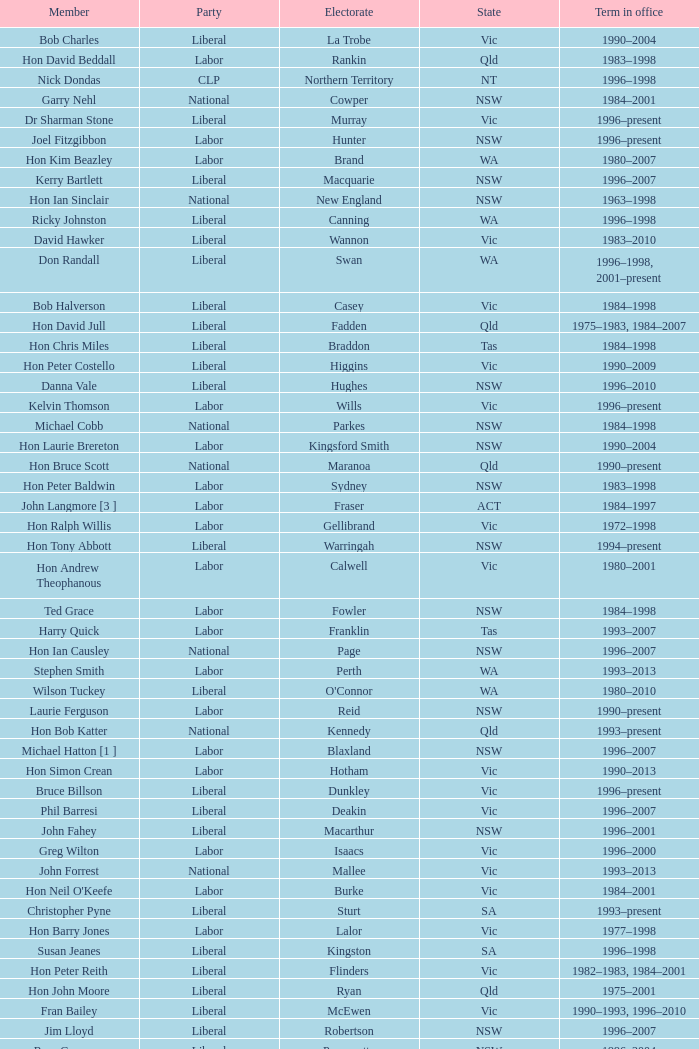Could you parse the entire table? {'header': ['Member', 'Party', 'Electorate', 'State', 'Term in office'], 'rows': [['Bob Charles', 'Liberal', 'La Trobe', 'Vic', '1990–2004'], ['Hon David Beddall', 'Labor', 'Rankin', 'Qld', '1983–1998'], ['Nick Dondas', 'CLP', 'Northern Territory', 'NT', '1996–1998'], ['Garry Nehl', 'National', 'Cowper', 'NSW', '1984–2001'], ['Dr Sharman Stone', 'Liberal', 'Murray', 'Vic', '1996–present'], ['Joel Fitzgibbon', 'Labor', 'Hunter', 'NSW', '1996–present'], ['Hon Kim Beazley', 'Labor', 'Brand', 'WA', '1980–2007'], ['Kerry Bartlett', 'Liberal', 'Macquarie', 'NSW', '1996–2007'], ['Hon Ian Sinclair', 'National', 'New England', 'NSW', '1963–1998'], ['Ricky Johnston', 'Liberal', 'Canning', 'WA', '1996–1998'], ['David Hawker', 'Liberal', 'Wannon', 'Vic', '1983–2010'], ['Don Randall', 'Liberal', 'Swan', 'WA', '1996–1998, 2001–present'], ['Bob Halverson', 'Liberal', 'Casey', 'Vic', '1984–1998'], ['Hon David Jull', 'Liberal', 'Fadden', 'Qld', '1975–1983, 1984–2007'], ['Hon Chris Miles', 'Liberal', 'Braddon', 'Tas', '1984–1998'], ['Hon Peter Costello', 'Liberal', 'Higgins', 'Vic', '1990–2009'], ['Danna Vale', 'Liberal', 'Hughes', 'NSW', '1996–2010'], ['Kelvin Thomson', 'Labor', 'Wills', 'Vic', '1996–present'], ['Michael Cobb', 'National', 'Parkes', 'NSW', '1984–1998'], ['Hon Laurie Brereton', 'Labor', 'Kingsford Smith', 'NSW', '1990–2004'], ['Hon Bruce Scott', 'National', 'Maranoa', 'Qld', '1990–present'], ['Hon Peter Baldwin', 'Labor', 'Sydney', 'NSW', '1983–1998'], ['John Langmore [3 ]', 'Labor', 'Fraser', 'ACT', '1984–1997'], ['Hon Ralph Willis', 'Labor', 'Gellibrand', 'Vic', '1972–1998'], ['Hon Tony Abbott', 'Liberal', 'Warringah', 'NSW', '1994–present'], ['Hon Andrew Theophanous', 'Labor', 'Calwell', 'Vic', '1980–2001'], ['Ted Grace', 'Labor', 'Fowler', 'NSW', '1984–1998'], ['Harry Quick', 'Labor', 'Franklin', 'Tas', '1993–2007'], ['Hon Ian Causley', 'National', 'Page', 'NSW', '1996–2007'], ['Stephen Smith', 'Labor', 'Perth', 'WA', '1993–2013'], ['Wilson Tuckey', 'Liberal', "O'Connor", 'WA', '1980–2010'], ['Laurie Ferguson', 'Labor', 'Reid', 'NSW', '1990–present'], ['Hon Bob Katter', 'National', 'Kennedy', 'Qld', '1993–present'], ['Michael Hatton [1 ]', 'Labor', 'Blaxland', 'NSW', '1996–2007'], ['Hon Simon Crean', 'Labor', 'Hotham', 'Vic', '1990–2013'], ['Bruce Billson', 'Liberal', 'Dunkley', 'Vic', '1996–present'], ['Phil Barresi', 'Liberal', 'Deakin', 'Vic', '1996–2007'], ['John Fahey', 'Liberal', 'Macarthur', 'NSW', '1996–2001'], ['Greg Wilton', 'Labor', 'Isaacs', 'Vic', '1996–2000'], ['John Forrest', 'National', 'Mallee', 'Vic', '1993–2013'], ["Hon Neil O'Keefe", 'Labor', 'Burke', 'Vic', '1984–2001'], ['Christopher Pyne', 'Liberal', 'Sturt', 'SA', '1993–present'], ['Hon Barry Jones', 'Labor', 'Lalor', 'Vic', '1977–1998'], ['Susan Jeanes', 'Liberal', 'Kingston', 'SA', '1996–1998'], ['Hon Peter Reith', 'Liberal', 'Flinders', 'Vic', '1982–1983, 1984–2001'], ['Hon John Moore', 'Liberal', 'Ryan', 'Qld', '1975–2001'], ['Fran Bailey', 'Liberal', 'McEwen', 'Vic', '1990–1993, 1996–2010'], ['Jim Lloyd', 'Liberal', 'Robertson', 'NSW', '1996–2007'], ['Ross Cameron', 'Liberal', 'Parramatta', 'NSW', '1996–2004'], ['Joanna Gash', 'Liberal', 'Gilmore', 'NSW', '1996–2013'], ['Harry Jenkins', 'Labor', 'Scullin', 'Vic', '1986–2013'], ['Hon Judi Moylan', 'Liberal', 'Pearce', 'WA', '1993–2013'], ['Warren Entsch', 'Liberal', 'Leichhardt', 'Qld', '1996–2007, 2010–present'], ['Larry Anthony', 'National', 'Richmond', 'NSW', '1996–2004'], ['Hon Arch Bevis', 'Labor', 'Brisbane', 'Qld', '1990–2010'], ['Gary Hardgrave', 'Liberal', 'Moreton', 'Qld', '1996–2007'], ['Hon Bob McMullan', 'Labor', 'Canberra', 'ACT', '1996–2010'], ['Pauline Hanson [4 ]', 'Independent/ ONP', 'Oxley', 'Qld', '1996–1998'], ['Andrea West', 'Liberal', 'Bowman', 'Qld', '1996–1998'], ['Anthony Albanese', 'Labor', 'Grayndler', 'NSW', '1996–present'], ['Kevin Andrews', 'Liberal', 'Menzies', 'Vic', '1991–present'], ['Hon Geoff Prosser', 'Liberal', 'Forrest', 'WA', '1987–2007'], ['Hon Dr Carmen Lawrence', 'Labor', 'Fremantle', 'WA', '1994–2007'], ['Hon Daryl Williams', 'Liberal', 'Tangney', 'WA', '1993–2004'], ['Paul Zammit', 'Liberal/Independent [6 ]', 'Lowe', 'NSW', '1996–1998'], ['Hon Michael Lee', 'Labor', 'Dobell', 'NSW', '1984–2001'], ['Hon Duncan Kerr', 'Labor', 'Denison', 'Tas', '1987–2010'], ['Colin Hollis', 'Labor', 'Throsby', 'NSW', '1984–2001'], ['Peter Lindsay', 'Liberal', 'Herbert', 'Qld', '1996–2010'], ['Peter Andren', 'Independent', 'Calare', 'NSW', '1996–2007'], ['Rod Sawford', 'Labor', 'Adelaide', 'SA', '1988–2007'], ['Graeme Campbell', 'Independent', 'Kalgoorlie', 'WA', '1980–1998'], ['Hon Lou Lieberman', 'Liberal', 'Indi', 'Vic', '1993–2001'], ['Mal Brough', 'Liberal', 'Longman', 'Qld', '1996–2007'], ['John Bradford [5 ]', 'Liberal/ CDP', 'McPherson', 'Qld', '1990–1998'], ['Robert McClelland', 'Labor', 'Barton', 'NSW', '1996–2013'], ['De-Anne Kelly', 'National', 'Dawson', 'Qld', '1996–2007'], ['Stewart McArthur', 'Liberal', 'Corangamite', 'Vic', '1984–2007'], ['Neil Andrew', 'Liberal', 'Wakefield', 'SA', '1983–2004'], ['Warren Truss', 'National', 'Wide Bay', 'Qld', '1990–present'], ['Elizabeth Grace', 'Liberal', 'Lilley', 'Qld', '1996–1998'], ['Alan Griffin', 'Labor', 'Bruce', 'Vic', '1993–present'], ['Hon John Sharp', 'National', 'Hume', 'NSW', '1984–1998'], ['Hon Martyn Evans', 'Labor', 'Bonython', 'SA', '1994–2004'], ['Hon John Anderson', 'National', 'Gwydir', 'NSW', '1989–2007'], ['Graeme McDougall', 'Liberal', 'Griffith', 'Qld', '1996–1998'], ['Hon Janice Crosio', 'Labor', 'Prospect', 'NSW', '1990–2004'], ['Trish Worth', 'Liberal', 'Adelaide', 'SA', '1996–2004'], ['Alex Somlyay', 'Liberal', 'Fairfax', 'Qld', '1990–2013'], ['Stephen Mutch', 'Liberal', 'Cook', 'NSW', '1996–1998'], ['Annette Ellis', 'Labor', 'Namadgi', 'ACT', '1996–2010'], ['Dr Brendan Nelson', 'Liberal', 'Bradfield', 'NSW', '1996–2009'], ['Jenny Macklin', 'Labor', 'Jagajaga', 'Vic', '1996–present'], ['Hon Roger Price', 'Labor', 'Chifley', 'NSW', '1984–2010'], ['Peter Slipper', 'Liberal', 'Fisher', 'Qld', '1984–1987, 1993–2013'], ['Frank Mossfield', 'Labor', 'Greenway', 'NSW', '1996–2004'], ['Richard Evans', 'Liberal', 'Cowan', 'WA', '1993–1998'], ['Hon Dr David Kemp', 'Liberal', 'Goldstein', 'Vic', '1990–2004'], ['Hon Dick Adams', 'Labor', 'Lyons', 'Tas', '1993–2013'], ['Hon Ian McLachlan', 'Liberal', 'Barker', 'SA', '1990–1998'], ['Paul Keating [1 ]', 'Labor', 'Blaxland', 'NSW', '1969–1996'], ['Hon Tim Fischer', 'National', 'Farrer', 'NSW', '1984–2001'], ['Alan Cadman', 'Liberal', 'Mitchell', 'NSW', '1974–2007'], ['Bill Taylor', 'Liberal', 'Groom', 'Qld', '1988–1998'], ['Bob Sercombe', 'Labor', 'Maribyrnong', 'Vic', '1996–2007'], ['Lindsay Tanner', 'Labor', 'Melbourne', 'Vic', '1993–2010'], ['Mark Vaile', 'National', 'Lyne', 'NSW', '1993–2008'], ['Teresa Gambaro', 'Liberal', 'Petrie', 'Qld', '1996–2007, 2010–present'], ['Bob Baldwin', 'Liberal', 'Paterson', 'NSW', '1996–present'], ['Hon Bronwyn Bishop', 'Liberal', 'Mackellar', 'NSW', '1994–present'], ['Peter Nugent', 'Liberal', 'Aston', 'Vic', '1990–2001'], ['Noel Hicks', 'National', 'Riverina', 'NSW', '1980–1998'], ['Hon John Howard', 'Liberal', 'Bennelong', 'NSW', '1974–2007'], ["Gavan O'Connor", 'Labor', 'Corio', 'Vic', '1993–2007'], ['Michael Ronaldson', 'Liberal', 'Ballarat', 'Vic', '1990–2001'], ['Paul Filing', 'Independent', 'Moore', 'WA', '1990–1998'], ['Hon Peter Morris', 'Labor', 'Shortland', 'NSW', '1972–1998'], ['Jackie Kelly [2 ]', 'Liberal', 'Lindsay', 'NSW', '1996–2007'], ['Joe Hockey', 'Liberal', 'North Sydney', 'NSW', '1996–present'], ['Gary Nairn', 'Liberal', 'Eden-Monaro', 'NSW', '1996–2007'], ['Eoin Cameron', 'Liberal', 'Stirling', 'WA', '1993–1998'], ['Mark Latham', 'Labor', 'Werriwa', 'NSW', '1994–2005'], ['Hon Bruce Reid', 'Liberal', 'Bendigo', 'Vic', '1990–1998'], ['Allan Morris', 'Labor', 'Newcastle', 'NSW', '1983–2001'], ['Hon Stephen Martin', 'Labor', 'Cunningham', 'NSW', '1984–2002'], ['Hon Andrew Thomson', 'Liberal', 'Wentworth', 'NSW', '1995–2001'], ['Daryl Melham', 'Labor', 'Banks', 'NSW', '1990–2013'], ['Christine Gallus', 'Liberal', 'Hindmarsh', 'SA', '1990–2004'], ['Hon Alexander Downer', 'Liberal', 'Mayo', 'SA', '1984–2008'], ['Paul Neville', 'National', 'Hinkler', 'Qld', '1993–2013'], ['Hon Philip Ruddock', 'Liberal', 'Berowra', 'NSW', '1973–present'], ['Dr Andrew Southcott', 'Liberal', 'Boothby', 'SA', '1996–present'], ['Kay Elson', 'Liberal', 'Forde', 'Qld', '1996–2007'], ['Hon Gareth Evans', 'Labor', 'Holt', 'Vic', '1996–1999'], ['Hon Peter McGauran', 'National', 'Gippsland', 'Vic', '1983–2008'], ['Hon Michael Wooldridge', 'Liberal', 'Casey', 'Vic', '1987–2001'], ['Steve Dargavel [3 ]', 'Labor', 'Fraser', 'ACT', '1997–1998'], ['Martin Ferguson', 'Labor', 'Batman', 'Vic', '1996–2013'], ['Russell Broadbent', 'Liberal', 'McMillan', 'Vic', '1990–1993, 1996–1998 2004–present'], ['Allan Rocher', 'Independent', 'Curtin', 'WA', '1981–1998'], ['Kathy Sullivan', 'Liberal', 'Moncrieff', 'Qld', '1984–2001'], ['Paul Marek', 'National', 'Capricornia', 'Qld', '1996–1998'], ['Petro Georgiou', 'Liberal', 'Kooyong', 'Vic', '1994–2010'], ['Hon Warwick Smith', 'Liberal', 'Bass', 'Tas', '1984–1993, 1996–1998'], ['Hon Bob Brown', 'Labor', 'Charlton', 'NSW', '1980–1998'], ['Tony Smith', 'Liberal/Independent [7 ]', 'Dickson', 'Qld', '1996–1998'], ['Hon Clyde Holding', 'Labor', 'Melbourne Ports', 'Vic', '1977–1998'], ['Trish Draper', 'Liberal', 'Makin', 'SA', '1996–2007'], ['Hon Leo McLeay', 'Labor', 'Watson', 'NSW', '1979–2004'], ['Barry Wakelin', 'Liberal', 'Grey', 'SA', '1993–2007']]} In what state was the electorate fowler? NSW. 